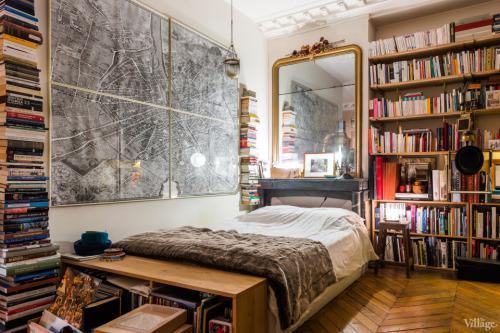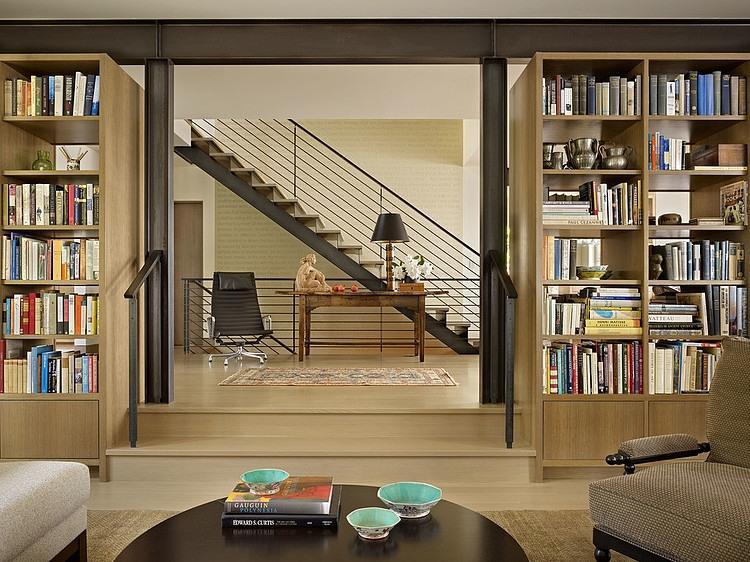The first image is the image on the left, the second image is the image on the right. Assess this claim about the two images: "In at least one of the images there is a lamp suspended on a visible chain from the ceiling.". Correct or not? Answer yes or no. Yes. The first image is the image on the left, the second image is the image on the right. Analyze the images presented: Is the assertion "There is a fireplace in at least one of the images." valid? Answer yes or no. No. 